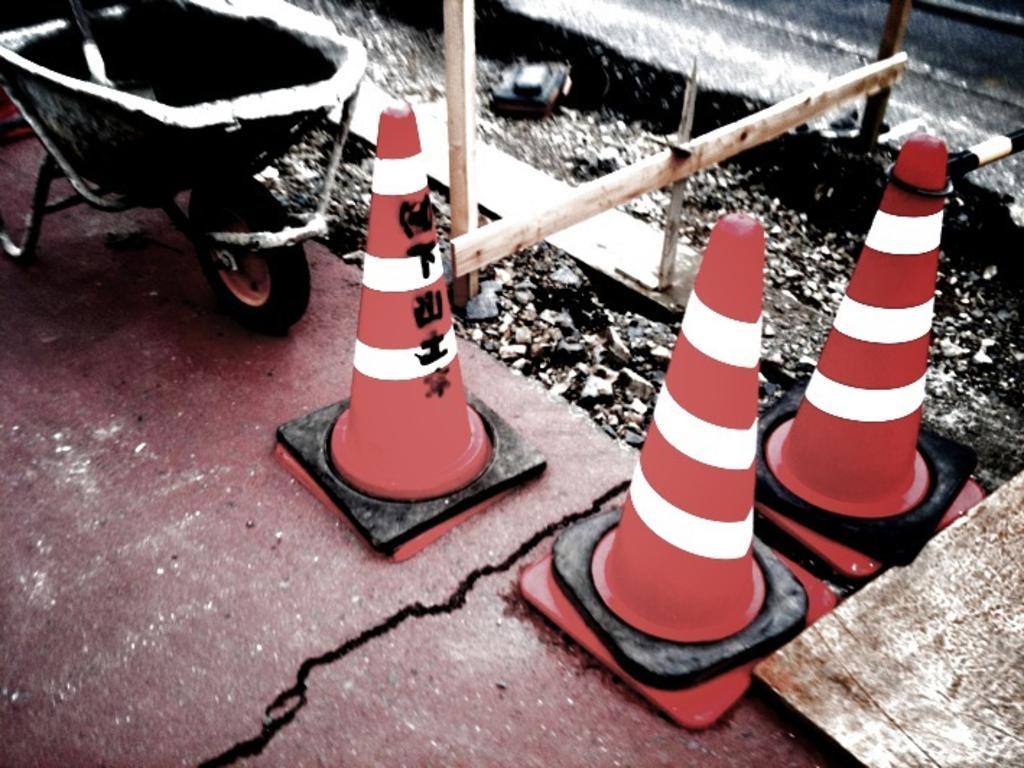Describe this image in one or two sentences. In the picture I can see traffic cones, wooden poles and some other objects on the ground. 